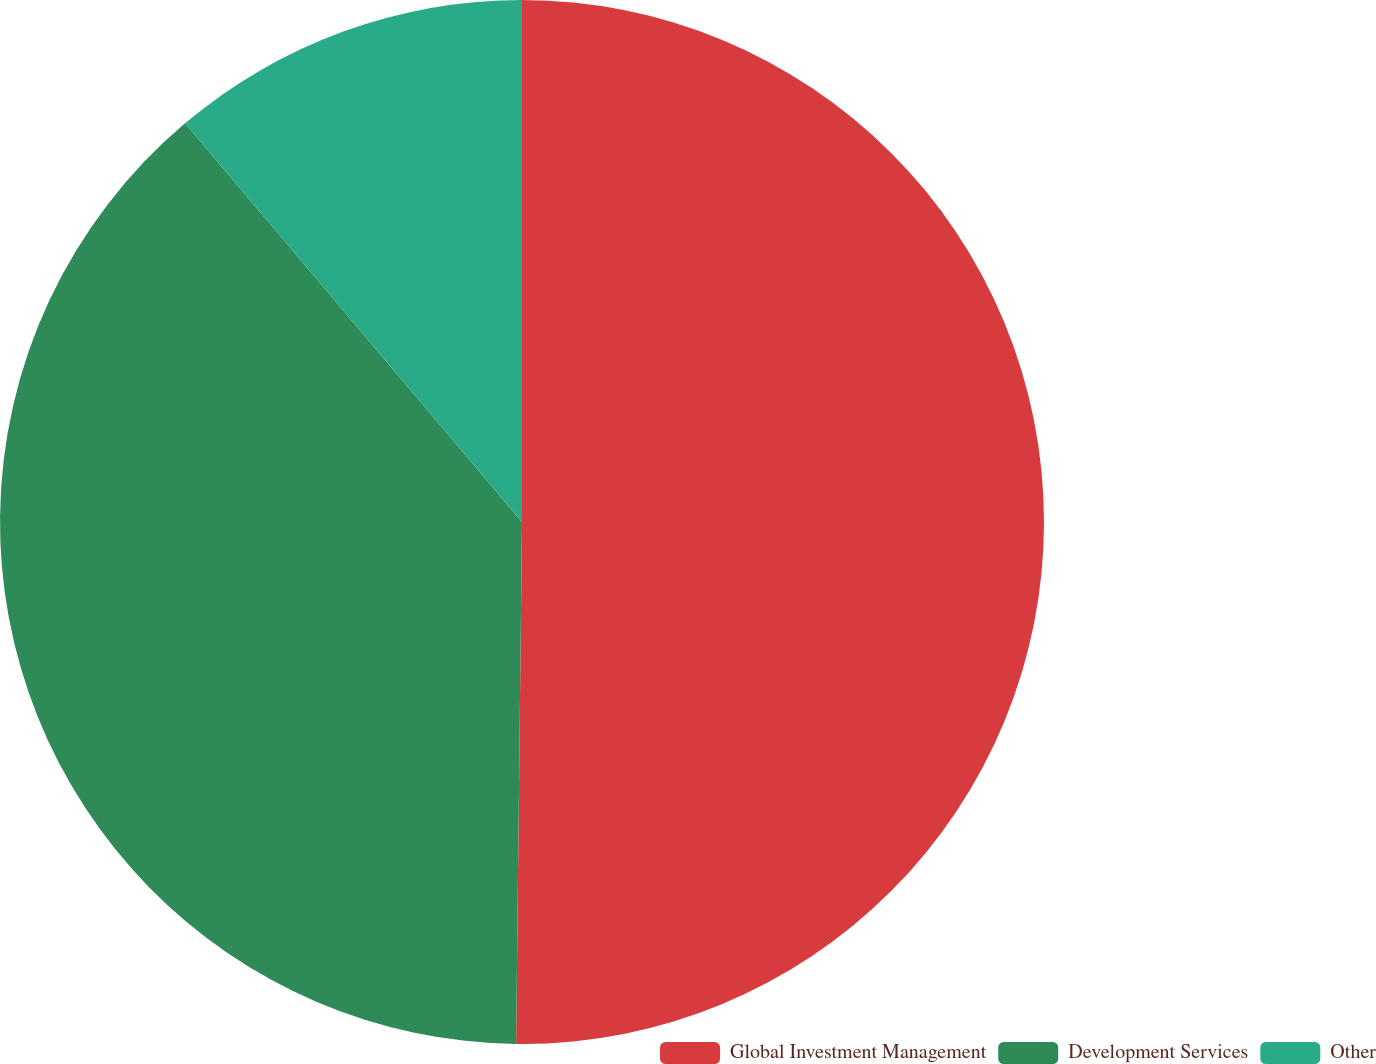Convert chart. <chart><loc_0><loc_0><loc_500><loc_500><pie_chart><fcel>Global Investment Management<fcel>Development Services<fcel>Other<nl><fcel>50.18%<fcel>38.65%<fcel>11.17%<nl></chart> 